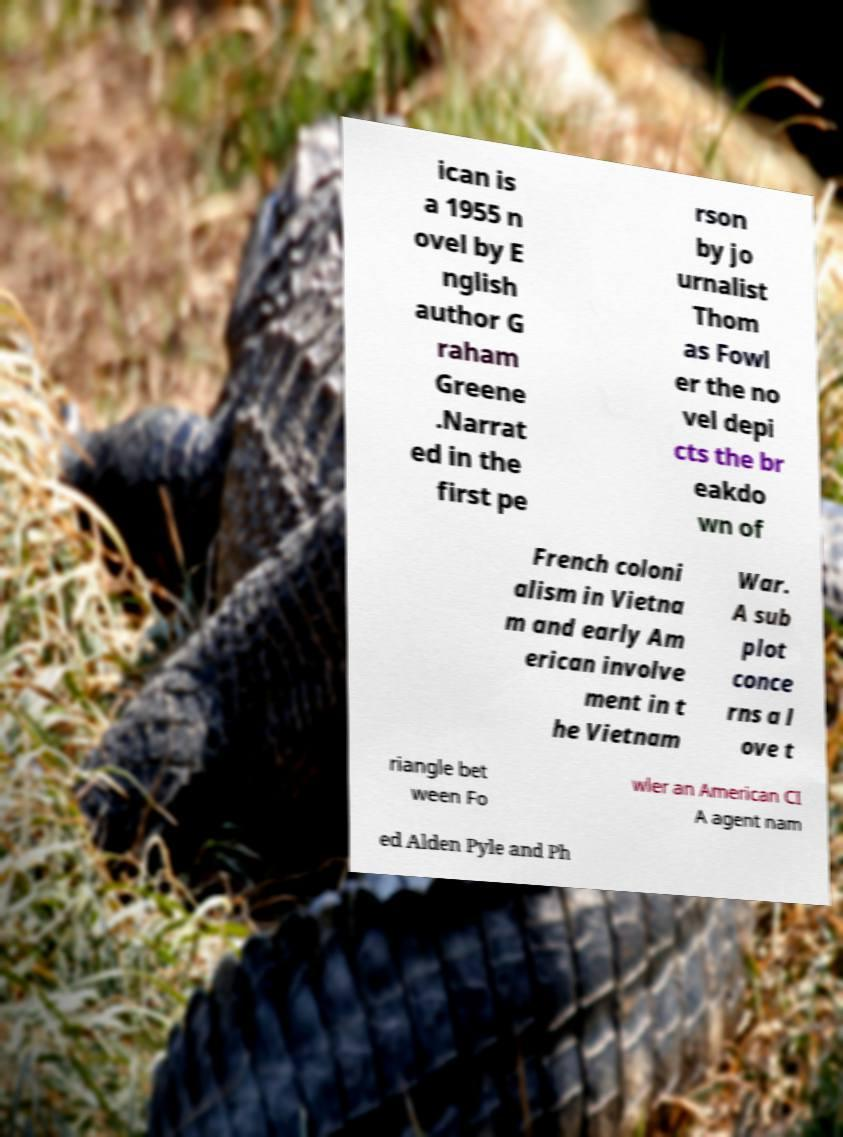Can you read and provide the text displayed in the image?This photo seems to have some interesting text. Can you extract and type it out for me? ican is a 1955 n ovel by E nglish author G raham Greene .Narrat ed in the first pe rson by jo urnalist Thom as Fowl er the no vel depi cts the br eakdo wn of French coloni alism in Vietna m and early Am erican involve ment in t he Vietnam War. A sub plot conce rns a l ove t riangle bet ween Fo wler an American CI A agent nam ed Alden Pyle and Ph 